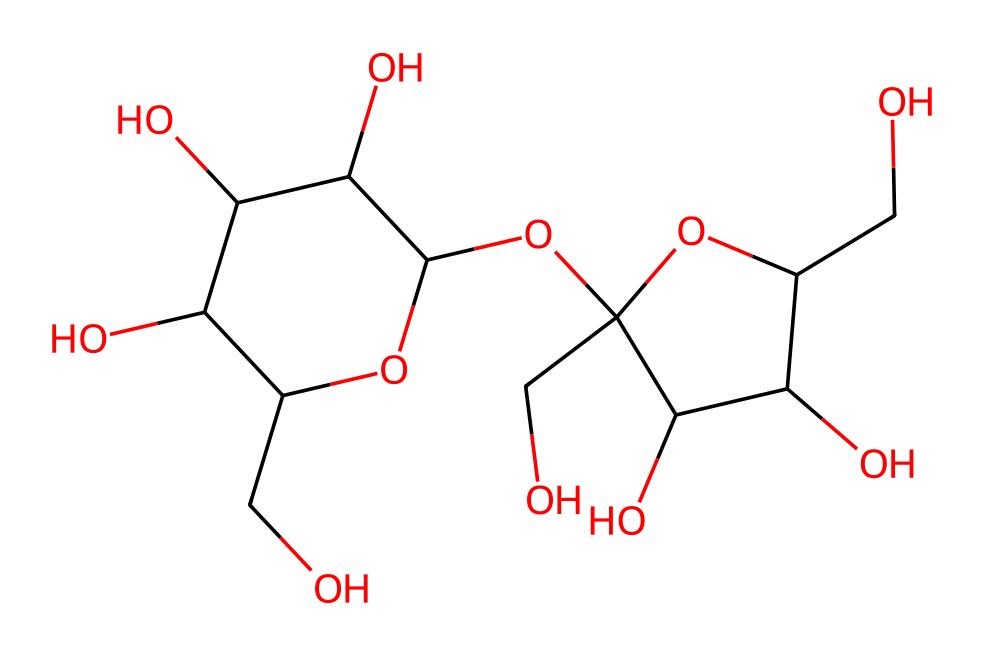What is the molecular formula of sucrose? To determine the molecular formula, count the number of carbon (C), hydrogen (H), and oxygen (O) atoms in the chemical structure. The counted atoms give us C12H22O11 for sucrose.
Answer: C12H22O11 How many rings are present in the structure of sucrose? The structure of sucrose consists of two cyclic structures (rings) derived from its glucose and fructose units, each forming a ring. Counting these, we find that there are 2 rings.
Answer: 2 What type of glycosidic bond is found in sucrose? The bond connecting glucose and fructose in sucrose is a α(1→2) glycosidic bond. This type refers to the specific carbon atoms involved in the bond (C1 of glucose and C2 of fructose), indicating that it is derived from alpha-D-glucose and beta-D-fructose.
Answer: α(1→2) What is the total number of hydroxyl (−OH) groups present in sucrose? A hydroxyl group (-OH) is present on each carbon except the ones involved in the glycosidic bond. Counting all visible -OH groups in the structure gives a total of 5 hydroxyl groups.
Answer: 5 What is the main functional group present in sucrose? The primary functional group in carbohydrates like sucrose is the hydroxyl group (-OH), which is represented multiple times within the structure. It significantly contributes to the molecule's solubility and chemical reactivity.
Answer: hydroxyl Which simple sugars are linked together to form sucrose? Sucrose is composed of two simple sugars: glucose and fructose. The structure can be recognized as being formed by the joining of these two monosaccharide units.
Answer: glucose and fructose 